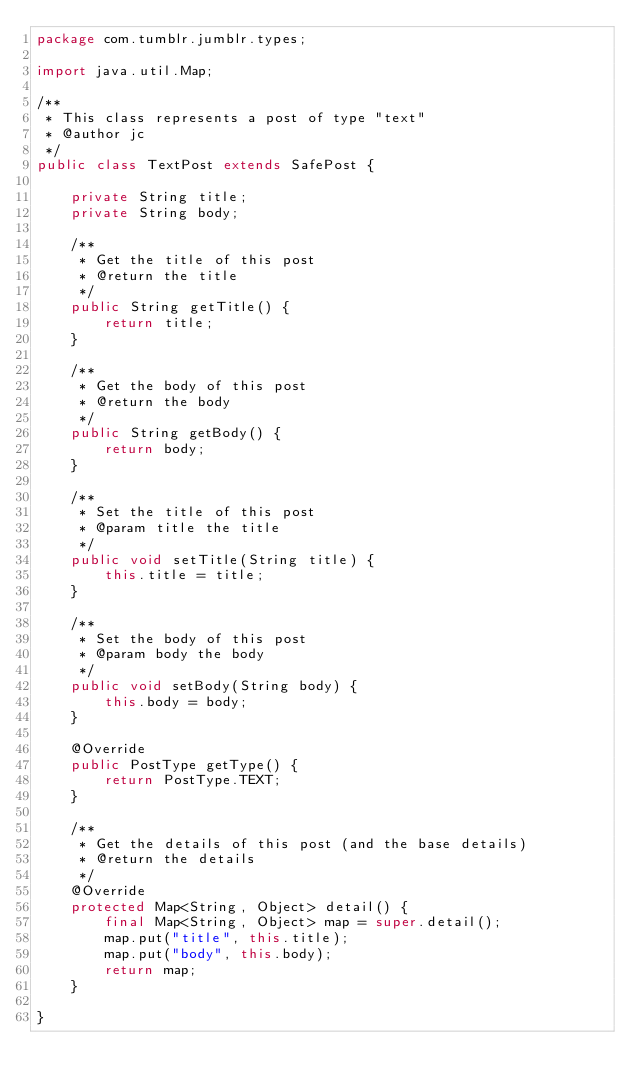Convert code to text. <code><loc_0><loc_0><loc_500><loc_500><_Java_>package com.tumblr.jumblr.types;

import java.util.Map;

/**
 * This class represents a post of type "text"
 * @author jc
 */
public class TextPost extends SafePost {

    private String title;
    private String body;

    /**
     * Get the title of this post
     * @return the title
     */
    public String getTitle() {
        return title;
    }

    /**
     * Get the body of this post
     * @return the body
     */
    public String getBody() {
        return body;
    }

    /**
     * Set the title of this post
     * @param title the title
     */
    public void setTitle(String title) {
        this.title = title;
    }

    /**
     * Set the body of this post
     * @param body the body
     */
    public void setBody(String body) {
        this.body = body;
    }

    @Override
    public PostType getType() {
        return PostType.TEXT;
    }

    /**
     * Get the details of this post (and the base details)
     * @return the details
     */
    @Override
    protected Map<String, Object> detail() {
        final Map<String, Object> map = super.detail();
        map.put("title", this.title);
        map.put("body", this.body);
        return map;
    }

}
</code> 